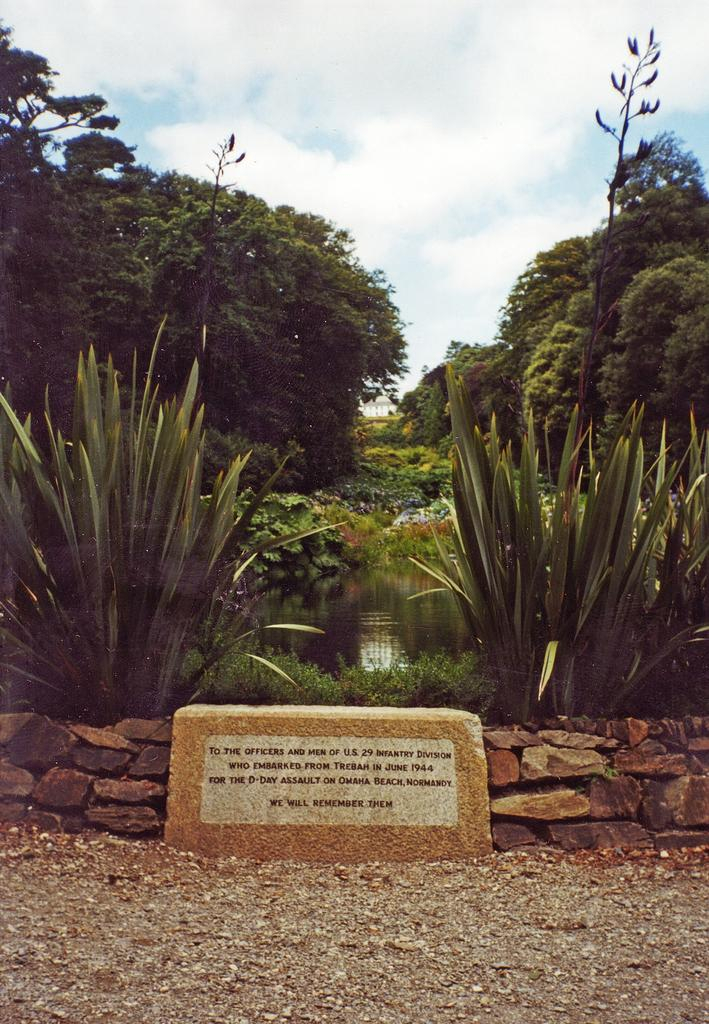What type of wall is shown in the image? There is a wall made up of rocks in the image. What other natural elements can be seen in the image? There are plants and water visible in the image. What is visible in the background of the image? There are trees and the sky visible in the background of the image. How is the paste being used in the image? There is no paste present in the image. 